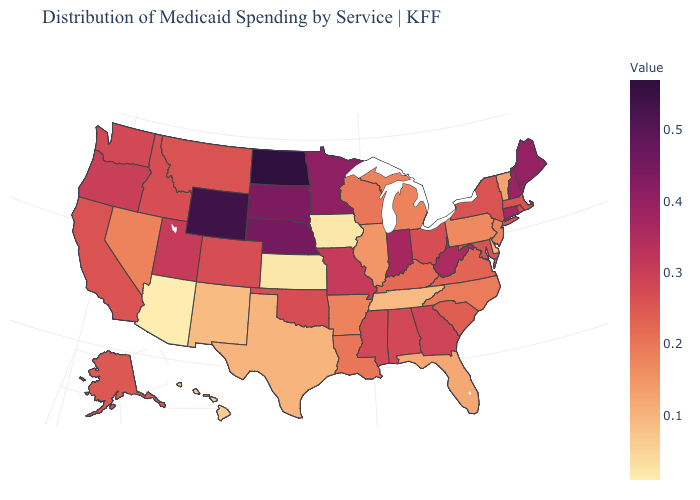Which states have the lowest value in the MidWest?
Short answer required. Iowa, Kansas. Does Alabama have a higher value than Wyoming?
Write a very short answer. No. Does Texas have the lowest value in the USA?
Write a very short answer. No. Does Alaska have the highest value in the West?
Answer briefly. No. Does Vermont have the lowest value in the USA?
Short answer required. No. Does Texas have a higher value than Kansas?
Answer briefly. Yes. Which states have the highest value in the USA?
Write a very short answer. North Dakota. Among the states that border Vermont , does Massachusetts have the highest value?
Answer briefly. No. 